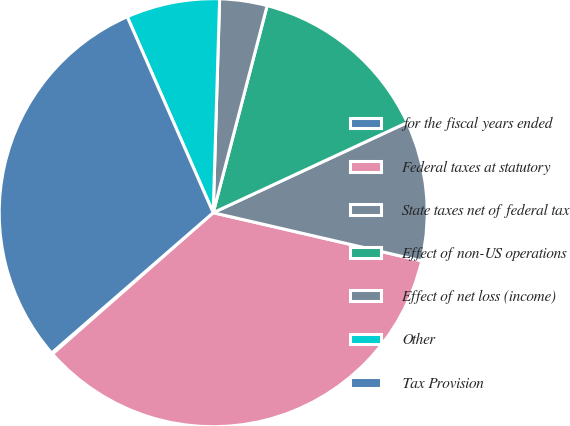<chart> <loc_0><loc_0><loc_500><loc_500><pie_chart><fcel>for the fiscal years ended<fcel>Federal taxes at statutory<fcel>State taxes net of federal tax<fcel>Effect of non-US operations<fcel>Effect of net loss (income)<fcel>Other<fcel>Tax Provision<nl><fcel>0.1%<fcel>34.91%<fcel>10.54%<fcel>14.02%<fcel>3.58%<fcel>7.06%<fcel>29.8%<nl></chart> 